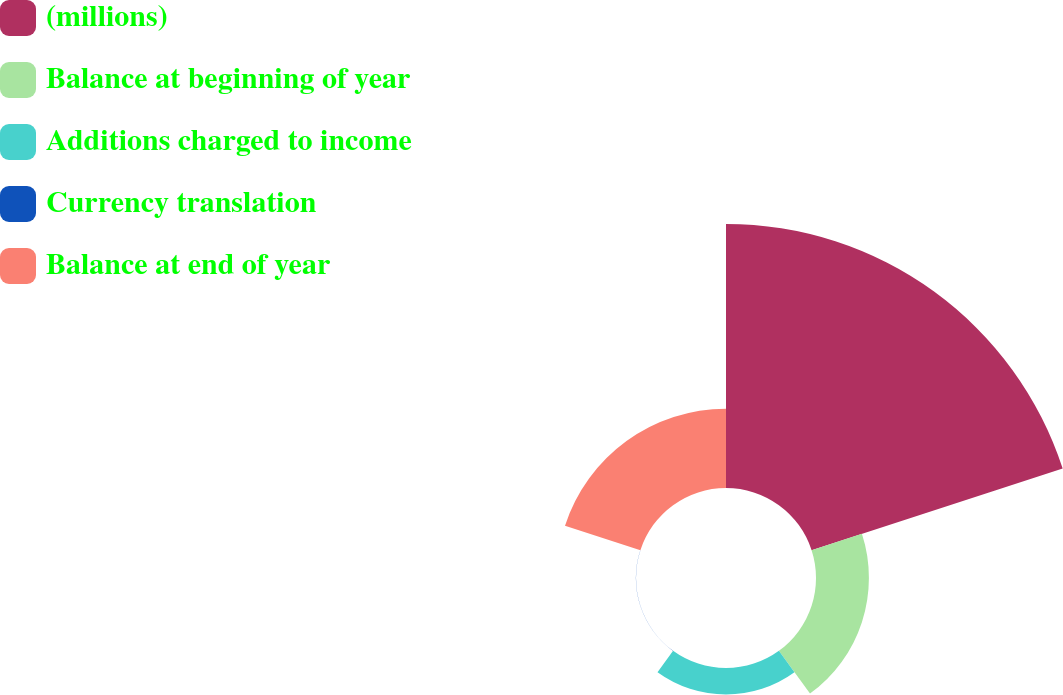Convert chart to OTSL. <chart><loc_0><loc_0><loc_500><loc_500><pie_chart><fcel>(millions)<fcel>Balance at beginning of year<fcel>Additions charged to income<fcel>Currency translation<fcel>Balance at end of year<nl><fcel>62.43%<fcel>12.51%<fcel>6.27%<fcel>0.03%<fcel>18.75%<nl></chart> 